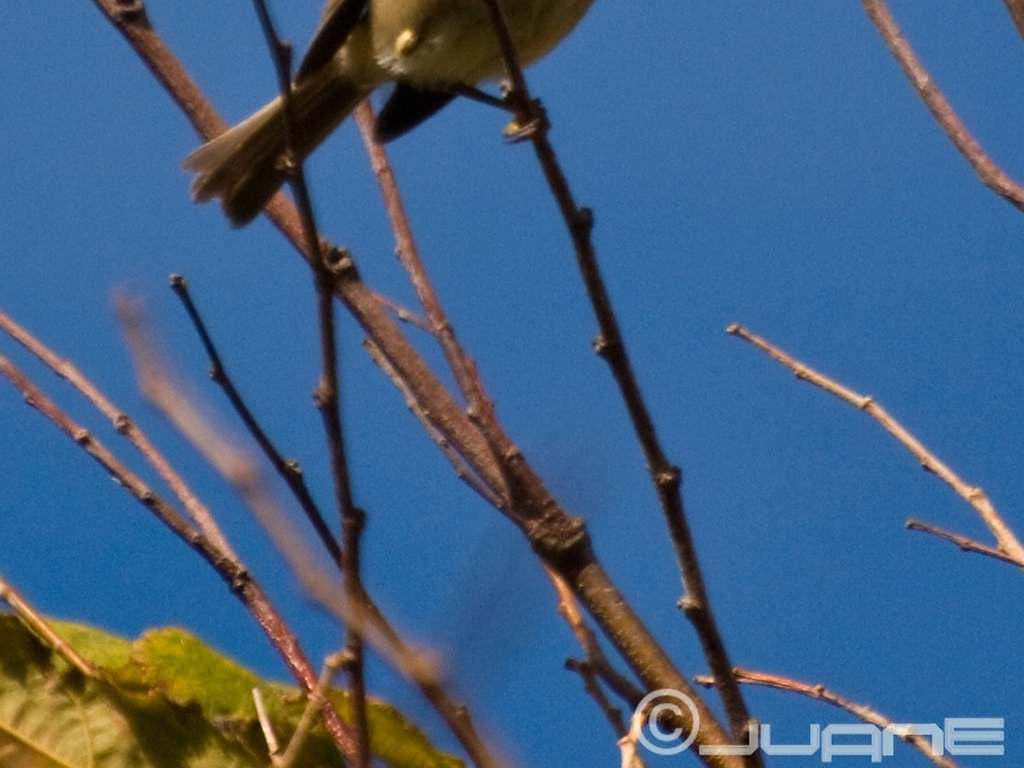What time of day does it seem like the photo was captured? Considering the brightness of the light and the shadow's absence, it's likely that the photo was taken during the midday hours when the sun is high in the sky, resulting in fewer harsh shadows. 